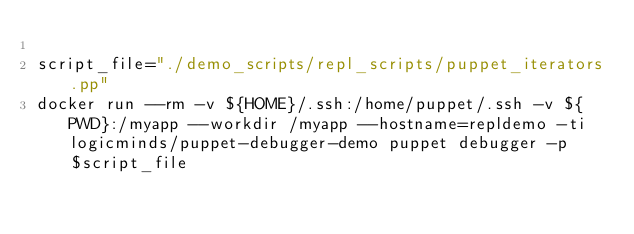Convert code to text. <code><loc_0><loc_0><loc_500><loc_500><_Bash_>
script_file="./demo_scripts/repl_scripts/puppet_iterators.pp"
docker run --rm -v ${HOME}/.ssh:/home/puppet/.ssh -v ${PWD}:/myapp --workdir /myapp --hostname=repldemo -ti logicminds/puppet-debugger-demo puppet debugger -p $script_file

</code> 